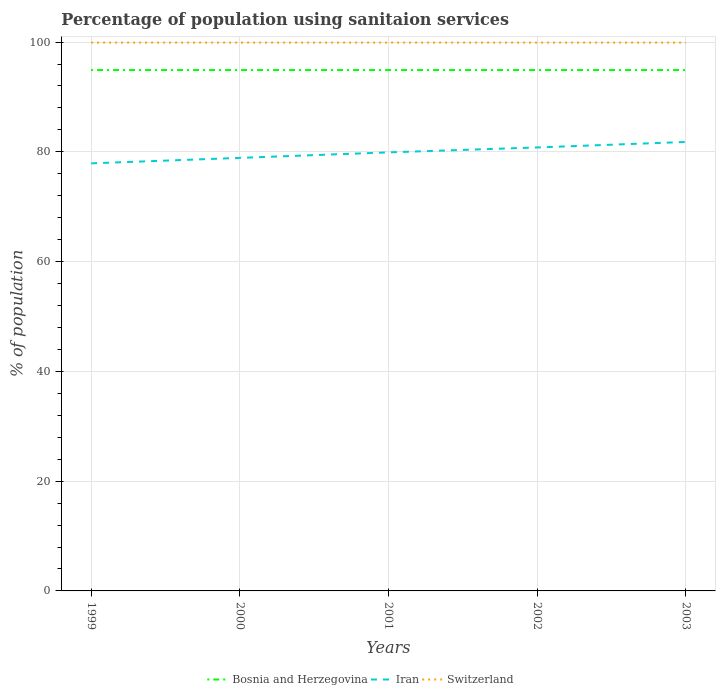How many different coloured lines are there?
Keep it short and to the point. 3. Does the line corresponding to Bosnia and Herzegovina intersect with the line corresponding to Switzerland?
Offer a very short reply. No. Is the number of lines equal to the number of legend labels?
Your answer should be very brief. Yes. Across all years, what is the maximum percentage of population using sanitaion services in Switzerland?
Make the answer very short. 99.9. What is the difference between the highest and the second highest percentage of population using sanitaion services in Switzerland?
Your answer should be very brief. 0. What is the difference between the highest and the lowest percentage of population using sanitaion services in Iran?
Offer a terse response. 3. Is the percentage of population using sanitaion services in Switzerland strictly greater than the percentage of population using sanitaion services in Bosnia and Herzegovina over the years?
Keep it short and to the point. No. How many lines are there?
Keep it short and to the point. 3. How many years are there in the graph?
Keep it short and to the point. 5. Where does the legend appear in the graph?
Offer a terse response. Bottom center. How are the legend labels stacked?
Your response must be concise. Horizontal. What is the title of the graph?
Your answer should be very brief. Percentage of population using sanitaion services. Does "Yemen, Rep." appear as one of the legend labels in the graph?
Your response must be concise. No. What is the label or title of the Y-axis?
Your answer should be compact. % of population. What is the % of population of Bosnia and Herzegovina in 1999?
Provide a short and direct response. 94.9. What is the % of population of Iran in 1999?
Your answer should be very brief. 77.9. What is the % of population in Switzerland in 1999?
Give a very brief answer. 99.9. What is the % of population of Bosnia and Herzegovina in 2000?
Your response must be concise. 94.9. What is the % of population in Iran in 2000?
Give a very brief answer. 78.9. What is the % of population of Switzerland in 2000?
Give a very brief answer. 99.9. What is the % of population of Bosnia and Herzegovina in 2001?
Provide a short and direct response. 94.9. What is the % of population in Iran in 2001?
Make the answer very short. 79.9. What is the % of population in Switzerland in 2001?
Your answer should be very brief. 99.9. What is the % of population of Bosnia and Herzegovina in 2002?
Your response must be concise. 94.9. What is the % of population of Iran in 2002?
Give a very brief answer. 80.8. What is the % of population in Switzerland in 2002?
Offer a very short reply. 99.9. What is the % of population in Bosnia and Herzegovina in 2003?
Provide a short and direct response. 94.9. What is the % of population of Iran in 2003?
Offer a very short reply. 81.8. What is the % of population of Switzerland in 2003?
Ensure brevity in your answer.  99.9. Across all years, what is the maximum % of population of Bosnia and Herzegovina?
Give a very brief answer. 94.9. Across all years, what is the maximum % of population of Iran?
Keep it short and to the point. 81.8. Across all years, what is the maximum % of population of Switzerland?
Ensure brevity in your answer.  99.9. Across all years, what is the minimum % of population of Bosnia and Herzegovina?
Ensure brevity in your answer.  94.9. Across all years, what is the minimum % of population in Iran?
Give a very brief answer. 77.9. Across all years, what is the minimum % of population of Switzerland?
Offer a terse response. 99.9. What is the total % of population of Bosnia and Herzegovina in the graph?
Offer a terse response. 474.5. What is the total % of population of Iran in the graph?
Provide a short and direct response. 399.3. What is the total % of population in Switzerland in the graph?
Provide a succinct answer. 499.5. What is the difference between the % of population of Bosnia and Herzegovina in 1999 and that in 2000?
Your answer should be compact. 0. What is the difference between the % of population in Switzerland in 1999 and that in 2000?
Give a very brief answer. 0. What is the difference between the % of population of Bosnia and Herzegovina in 1999 and that in 2001?
Ensure brevity in your answer.  0. What is the difference between the % of population of Bosnia and Herzegovina in 1999 and that in 2002?
Your answer should be very brief. 0. What is the difference between the % of population of Bosnia and Herzegovina in 1999 and that in 2003?
Make the answer very short. 0. What is the difference between the % of population of Iran in 1999 and that in 2003?
Provide a short and direct response. -3.9. What is the difference between the % of population of Bosnia and Herzegovina in 2000 and that in 2001?
Your answer should be compact. 0. What is the difference between the % of population in Iran in 2000 and that in 2001?
Provide a short and direct response. -1. What is the difference between the % of population in Switzerland in 2000 and that in 2001?
Your answer should be compact. 0. What is the difference between the % of population in Iran in 2000 and that in 2002?
Your response must be concise. -1.9. What is the difference between the % of population in Bosnia and Herzegovina in 2000 and that in 2003?
Your answer should be very brief. 0. What is the difference between the % of population of Switzerland in 2000 and that in 2003?
Ensure brevity in your answer.  0. What is the difference between the % of population of Bosnia and Herzegovina in 2001 and that in 2003?
Your response must be concise. 0. What is the difference between the % of population in Switzerland in 2001 and that in 2003?
Give a very brief answer. 0. What is the difference between the % of population in Iran in 2002 and that in 2003?
Give a very brief answer. -1. What is the difference between the % of population of Iran in 1999 and the % of population of Switzerland in 2000?
Keep it short and to the point. -22. What is the difference between the % of population in Iran in 1999 and the % of population in Switzerland in 2001?
Keep it short and to the point. -22. What is the difference between the % of population of Bosnia and Herzegovina in 1999 and the % of population of Iran in 2002?
Give a very brief answer. 14.1. What is the difference between the % of population in Iran in 1999 and the % of population in Switzerland in 2003?
Keep it short and to the point. -22. What is the difference between the % of population of Bosnia and Herzegovina in 2000 and the % of population of Iran in 2001?
Offer a very short reply. 15. What is the difference between the % of population of Iran in 2000 and the % of population of Switzerland in 2001?
Your answer should be compact. -21. What is the difference between the % of population in Bosnia and Herzegovina in 2000 and the % of population in Switzerland in 2003?
Your response must be concise. -5. What is the difference between the % of population of Bosnia and Herzegovina in 2001 and the % of population of Iran in 2002?
Give a very brief answer. 14.1. What is the difference between the % of population in Bosnia and Herzegovina in 2001 and the % of population in Switzerland in 2002?
Provide a short and direct response. -5. What is the difference between the % of population in Bosnia and Herzegovina in 2001 and the % of population in Switzerland in 2003?
Your answer should be very brief. -5. What is the difference between the % of population in Bosnia and Herzegovina in 2002 and the % of population in Switzerland in 2003?
Ensure brevity in your answer.  -5. What is the difference between the % of population of Iran in 2002 and the % of population of Switzerland in 2003?
Your answer should be compact. -19.1. What is the average % of population of Bosnia and Herzegovina per year?
Give a very brief answer. 94.9. What is the average % of population of Iran per year?
Make the answer very short. 79.86. What is the average % of population of Switzerland per year?
Keep it short and to the point. 99.9. In the year 1999, what is the difference between the % of population in Iran and % of population in Switzerland?
Offer a very short reply. -22. In the year 2000, what is the difference between the % of population in Bosnia and Herzegovina and % of population in Iran?
Provide a succinct answer. 16. In the year 2000, what is the difference between the % of population in Bosnia and Herzegovina and % of population in Switzerland?
Provide a succinct answer. -5. In the year 2000, what is the difference between the % of population of Iran and % of population of Switzerland?
Your response must be concise. -21. In the year 2001, what is the difference between the % of population in Bosnia and Herzegovina and % of population in Switzerland?
Ensure brevity in your answer.  -5. In the year 2002, what is the difference between the % of population of Bosnia and Herzegovina and % of population of Iran?
Your answer should be compact. 14.1. In the year 2002, what is the difference between the % of population of Iran and % of population of Switzerland?
Offer a terse response. -19.1. In the year 2003, what is the difference between the % of population of Bosnia and Herzegovina and % of population of Iran?
Offer a terse response. 13.1. In the year 2003, what is the difference between the % of population in Bosnia and Herzegovina and % of population in Switzerland?
Offer a very short reply. -5. In the year 2003, what is the difference between the % of population of Iran and % of population of Switzerland?
Make the answer very short. -18.1. What is the ratio of the % of population in Iran in 1999 to that in 2000?
Your answer should be compact. 0.99. What is the ratio of the % of population of Bosnia and Herzegovina in 1999 to that in 2001?
Provide a short and direct response. 1. What is the ratio of the % of population in Iran in 1999 to that in 2002?
Offer a very short reply. 0.96. What is the ratio of the % of population in Bosnia and Herzegovina in 1999 to that in 2003?
Your answer should be very brief. 1. What is the ratio of the % of population in Iran in 1999 to that in 2003?
Ensure brevity in your answer.  0.95. What is the ratio of the % of population of Iran in 2000 to that in 2001?
Your answer should be compact. 0.99. What is the ratio of the % of population of Bosnia and Herzegovina in 2000 to that in 2002?
Provide a succinct answer. 1. What is the ratio of the % of population in Iran in 2000 to that in 2002?
Give a very brief answer. 0.98. What is the ratio of the % of population in Switzerland in 2000 to that in 2002?
Make the answer very short. 1. What is the ratio of the % of population in Bosnia and Herzegovina in 2000 to that in 2003?
Keep it short and to the point. 1. What is the ratio of the % of population of Iran in 2000 to that in 2003?
Your answer should be very brief. 0.96. What is the ratio of the % of population of Switzerland in 2000 to that in 2003?
Give a very brief answer. 1. What is the ratio of the % of population of Bosnia and Herzegovina in 2001 to that in 2002?
Offer a very short reply. 1. What is the ratio of the % of population in Iran in 2001 to that in 2002?
Your answer should be compact. 0.99. What is the ratio of the % of population of Switzerland in 2001 to that in 2002?
Your answer should be very brief. 1. What is the ratio of the % of population of Bosnia and Herzegovina in 2001 to that in 2003?
Your answer should be compact. 1. What is the ratio of the % of population in Iran in 2001 to that in 2003?
Your answer should be compact. 0.98. What is the ratio of the % of population in Switzerland in 2001 to that in 2003?
Keep it short and to the point. 1. What is the difference between the highest and the second highest % of population in Bosnia and Herzegovina?
Give a very brief answer. 0. What is the difference between the highest and the second highest % of population in Switzerland?
Make the answer very short. 0. What is the difference between the highest and the lowest % of population of Bosnia and Herzegovina?
Your answer should be compact. 0. What is the difference between the highest and the lowest % of population of Switzerland?
Offer a terse response. 0. 